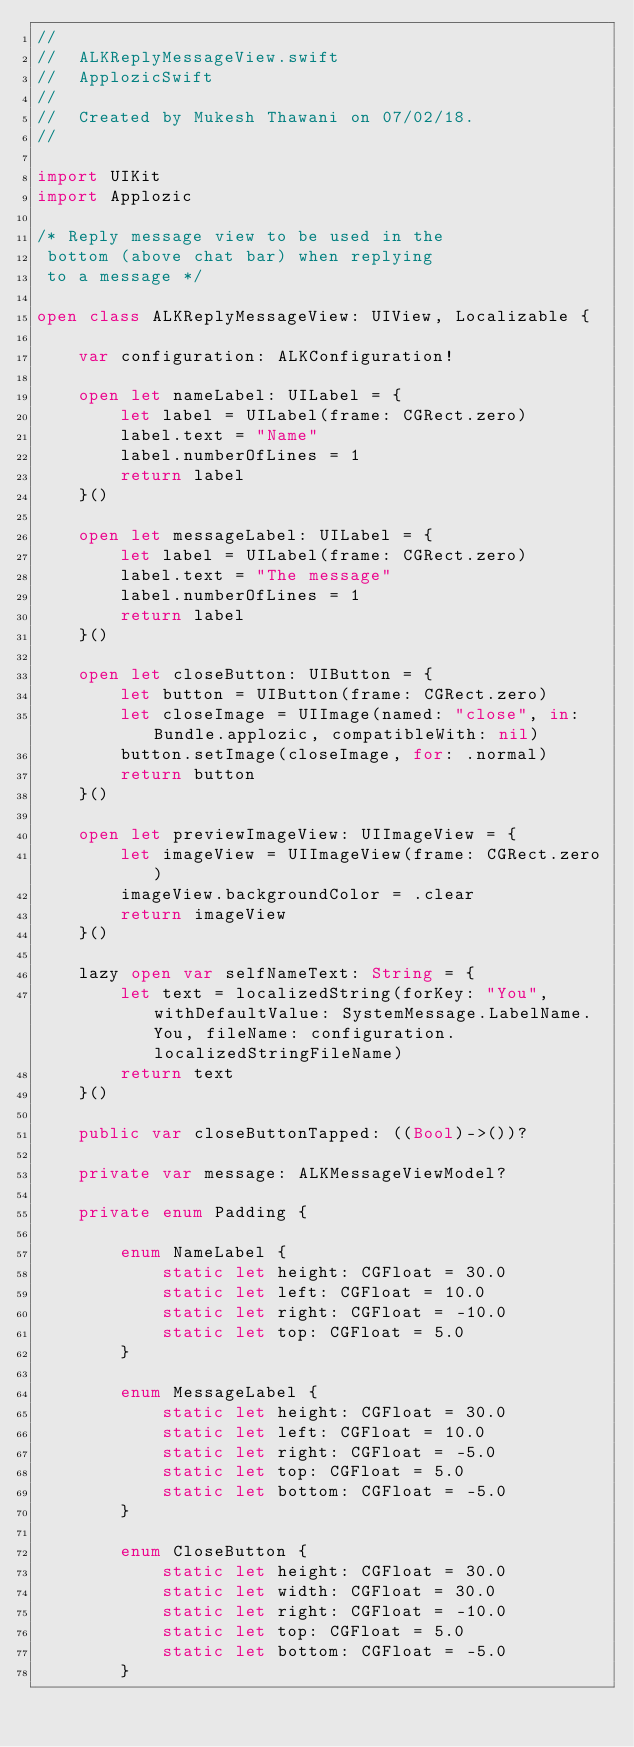<code> <loc_0><loc_0><loc_500><loc_500><_Swift_>//
//  ALKReplyMessageView.swift
//  ApplozicSwift
//
//  Created by Mukesh Thawani on 07/02/18.
//

import UIKit
import Applozic

/* Reply message view to be used in the
 bottom (above chat bar) when replying
 to a message */

open class ALKReplyMessageView: UIView, Localizable {
    
    var configuration: ALKConfiguration!
    
    open let nameLabel: UILabel = {
        let label = UILabel(frame: CGRect.zero)
        label.text = "Name"
        label.numberOfLines = 1
        return label
    }()

    open let messageLabel: UILabel = {
        let label = UILabel(frame: CGRect.zero)
        label.text = "The message"
        label.numberOfLines = 1
        return label
    }()

    open let closeButton: UIButton = {
        let button = UIButton(frame: CGRect.zero)
        let closeImage = UIImage(named: "close", in: Bundle.applozic, compatibleWith: nil)
        button.setImage(closeImage, for: .normal)
        return button
    }()

    open let previewImageView: UIImageView = {
        let imageView = UIImageView(frame: CGRect.zero)
        imageView.backgroundColor = .clear
        return imageView
    }()

    lazy open var selfNameText: String = {
        let text = localizedString(forKey: "You", withDefaultValue: SystemMessage.LabelName.You, fileName: configuration.localizedStringFileName)
        return text
    }()
    
    public var closeButtonTapped: ((Bool)->())?

    private var message: ALKMessageViewModel?

    private enum Padding {

        enum NameLabel {
            static let height: CGFloat = 30.0
            static let left: CGFloat = 10.0
            static let right: CGFloat = -10.0
            static let top: CGFloat = 5.0
        }

        enum MessageLabel {
            static let height: CGFloat = 30.0
            static let left: CGFloat = 10.0
            static let right: CGFloat = -5.0
            static let top: CGFloat = 5.0
            static let bottom: CGFloat = -5.0
        }

        enum CloseButton {
            static let height: CGFloat = 30.0
            static let width: CGFloat = 30.0
            static let right: CGFloat = -10.0
            static let top: CGFloat = 5.0
            static let bottom: CGFloat = -5.0
        }
</code> 